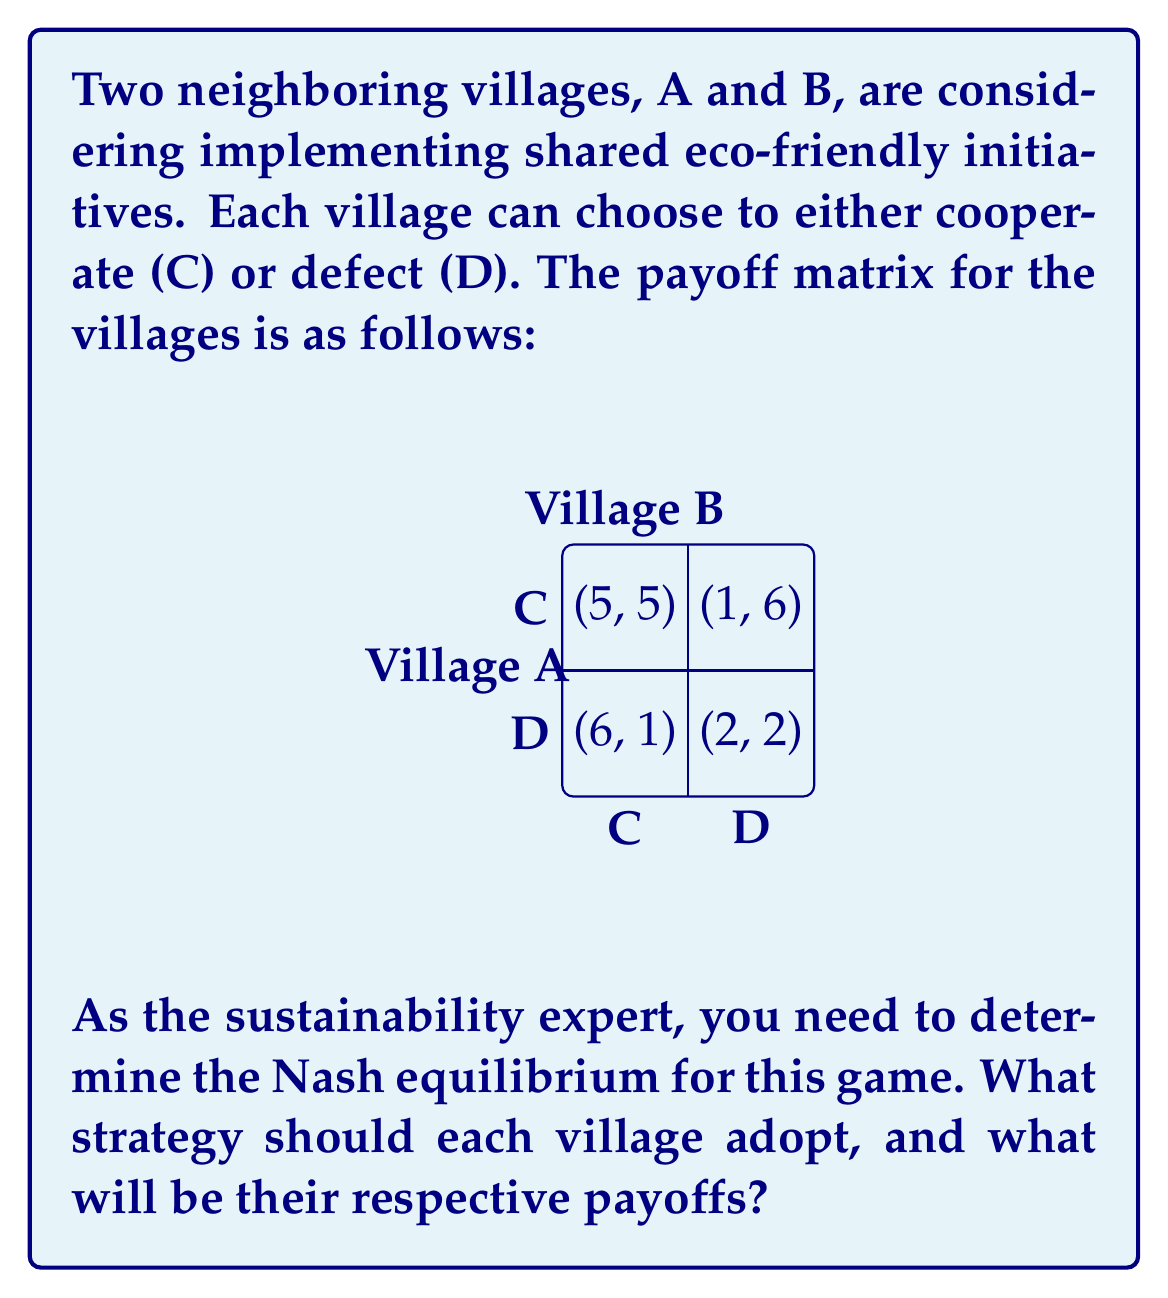Provide a solution to this math problem. To solve this problem, we need to find the Nash equilibrium, which is a state where no player can unilaterally improve their payoff by changing their strategy.

Step 1: Analyze Village A's strategies
- If Village B chooses C:
  * A choosing C gives payoff 5
  * A choosing D gives payoff 6
  * A prefers D when B chooses C
- If Village B chooses D:
  * A choosing C gives payoff 1
  * A choosing D gives payoff 2
  * A prefers D when B chooses D

Step 2: Analyze Village B's strategies
- If Village A chooses C:
  * B choosing C gives payoff 5
  * B choosing D gives payoff 6
  * B prefers D when A chooses C
- If Village A chooses D:
  * B choosing C gives payoff 1
  * B choosing D gives payoff 2
  * B prefers D when A chooses D

Step 3: Determine the Nash equilibrium
From the analysis, we can see that regardless of what the other village does, each village always has an incentive to choose D (defect). This makes (D, D) the Nash equilibrium of the game.

Step 4: Calculate the payoffs
When both villages choose D, their payoffs are (2, 2) according to the payoff matrix.

Therefore, the Nash equilibrium strategy for each village is to defect (D), and their respective payoffs will be 2 each.
Answer: Nash equilibrium: (D, D); Payoffs: (2, 2) 